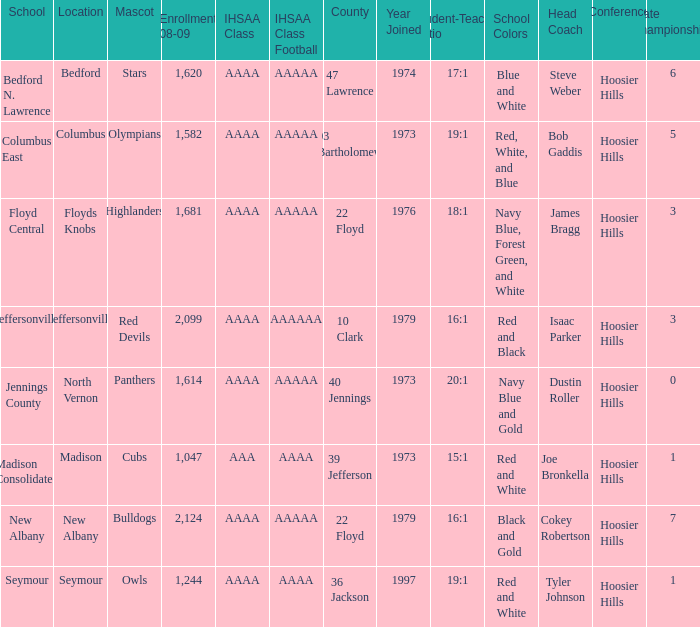What school is in 36 Jackson? Seymour. 